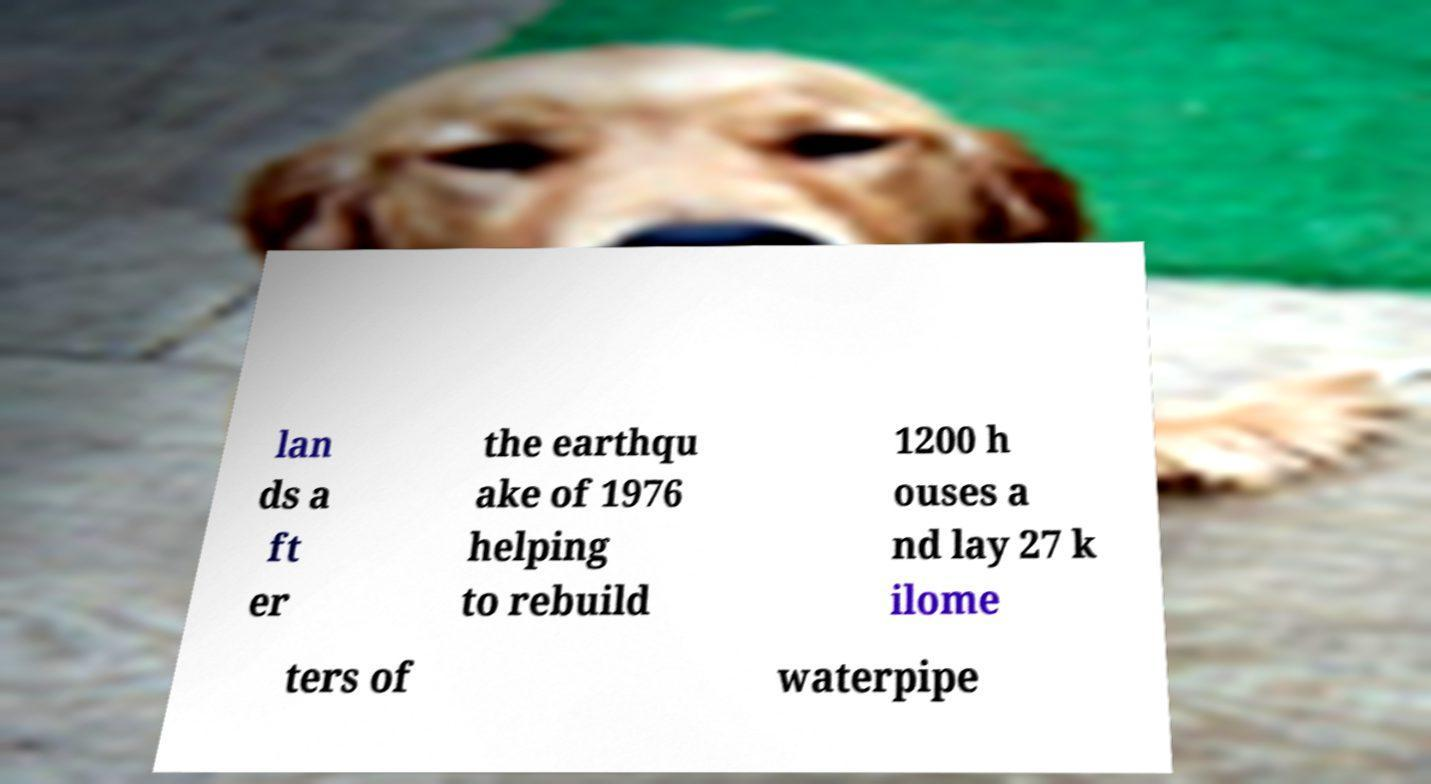Could you assist in decoding the text presented in this image and type it out clearly? lan ds a ft er the earthqu ake of 1976 helping to rebuild 1200 h ouses a nd lay 27 k ilome ters of waterpipe 